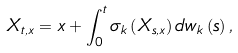Convert formula to latex. <formula><loc_0><loc_0><loc_500><loc_500>X _ { t , x } = x + \int _ { 0 } ^ { t } \sigma _ { k } \left ( X _ { s , x } \right ) { d w _ { k } } \left ( s \right ) ,</formula> 